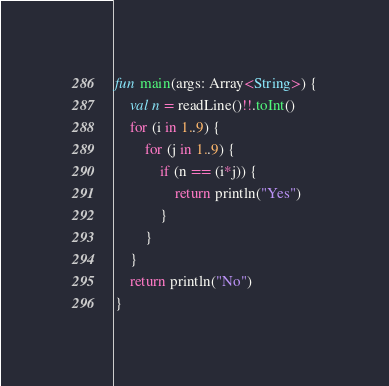Convert code to text. <code><loc_0><loc_0><loc_500><loc_500><_Kotlin_>fun main(args: Array<String>) {
    val n = readLine()!!.toInt()
    for (i in 1..9) {
        for (j in 1..9) {
            if (n == (i*j)) {
                return println("Yes")
            }
        }
    }
    return println("No")
}</code> 